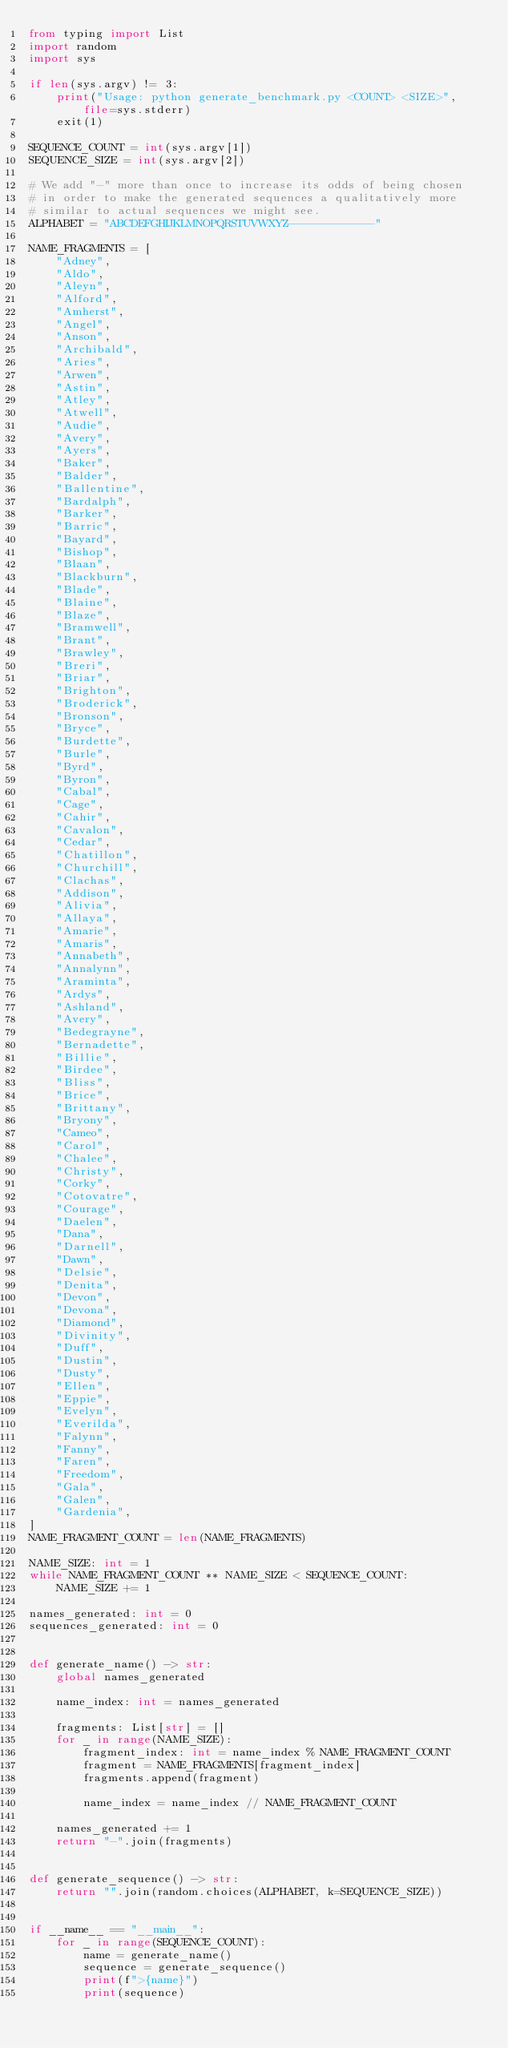Convert code to text. <code><loc_0><loc_0><loc_500><loc_500><_Python_>from typing import List
import random
import sys

if len(sys.argv) != 3:
    print("Usage: python generate_benchmark.py <COUNT> <SIZE>", file=sys.stderr)
    exit(1)

SEQUENCE_COUNT = int(sys.argv[1])
SEQUENCE_SIZE = int(sys.argv[2])

# We add "-" more than once to increase its odds of being chosen
# in order to make the generated sequences a qualitatively more
# similar to actual sequences we might see.
ALPHABET = "ABCDEFGHIJKLMNOPQRSTUVWXYZ-------------"

NAME_FRAGMENTS = [
    "Adney",
    "Aldo",
    "Aleyn",
    "Alford",
    "Amherst",
    "Angel",
    "Anson",
    "Archibald",
    "Aries",
    "Arwen",
    "Astin",
    "Atley",
    "Atwell",
    "Audie",
    "Avery",
    "Ayers",
    "Baker",
    "Balder",
    "Ballentine",
    "Bardalph",
    "Barker",
    "Barric",
    "Bayard",
    "Bishop",
    "Blaan",
    "Blackburn",
    "Blade",
    "Blaine",
    "Blaze",
    "Bramwell",
    "Brant",
    "Brawley",
    "Breri",
    "Briar",
    "Brighton",
    "Broderick",
    "Bronson",
    "Bryce",
    "Burdette",
    "Burle",
    "Byrd",
    "Byron",
    "Cabal",
    "Cage",
    "Cahir",
    "Cavalon",
    "Cedar",
    "Chatillon",
    "Churchill",
    "Clachas",
    "Addison",
    "Alivia",
    "Allaya",
    "Amarie",
    "Amaris",
    "Annabeth",
    "Annalynn",
    "Araminta",
    "Ardys",
    "Ashland",
    "Avery",
    "Bedegrayne",
    "Bernadette",
    "Billie",
    "Birdee",
    "Bliss",
    "Brice",
    "Brittany",
    "Bryony",
    "Cameo",
    "Carol",
    "Chalee",
    "Christy",
    "Corky",
    "Cotovatre",
    "Courage",
    "Daelen",
    "Dana",
    "Darnell",
    "Dawn",
    "Delsie",
    "Denita",
    "Devon",
    "Devona",
    "Diamond",
    "Divinity",
    "Duff",
    "Dustin",
    "Dusty",
    "Ellen",
    "Eppie",
    "Evelyn",
    "Everilda",
    "Falynn",
    "Fanny",
    "Faren",
    "Freedom",
    "Gala",
    "Galen",
    "Gardenia",
]
NAME_FRAGMENT_COUNT = len(NAME_FRAGMENTS)

NAME_SIZE: int = 1
while NAME_FRAGMENT_COUNT ** NAME_SIZE < SEQUENCE_COUNT:
    NAME_SIZE += 1

names_generated: int = 0
sequences_generated: int = 0


def generate_name() -> str:
    global names_generated

    name_index: int = names_generated

    fragments: List[str] = []
    for _ in range(NAME_SIZE):
        fragment_index: int = name_index % NAME_FRAGMENT_COUNT
        fragment = NAME_FRAGMENTS[fragment_index]
        fragments.append(fragment)

        name_index = name_index // NAME_FRAGMENT_COUNT

    names_generated += 1
    return "-".join(fragments)


def generate_sequence() -> str:
    return "".join(random.choices(ALPHABET, k=SEQUENCE_SIZE))


if __name__ == "__main__":
    for _ in range(SEQUENCE_COUNT):
        name = generate_name()
        sequence = generate_sequence()
        print(f">{name}")
        print(sequence)
</code> 